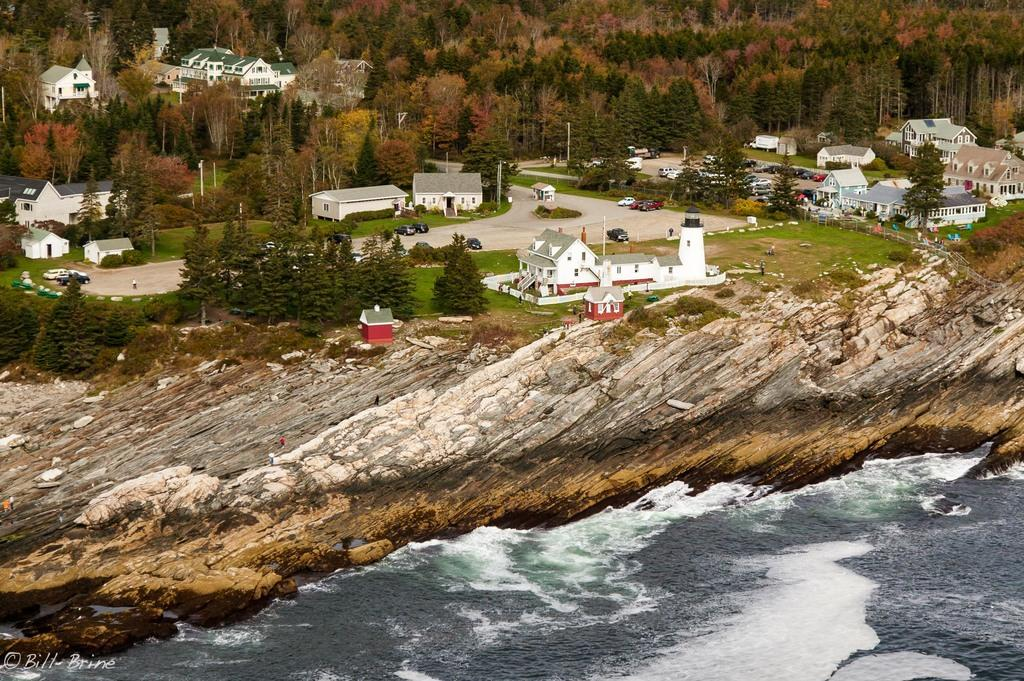What is the primary element visible in the image? There is water in the image. What type of structure can be seen in the image? There are houses in the image. What type of transportation is present in the image? There are vehicles on the roads in the image. What type of vegetation is present in the image? There are trees and grass in the image. What type of man-made structures are present in the image? There are poles in the image. How many baby snails can be seen crawling on the ducks in the image? There are no ducks or snails present in the image, so it is not possible to answer that question. 